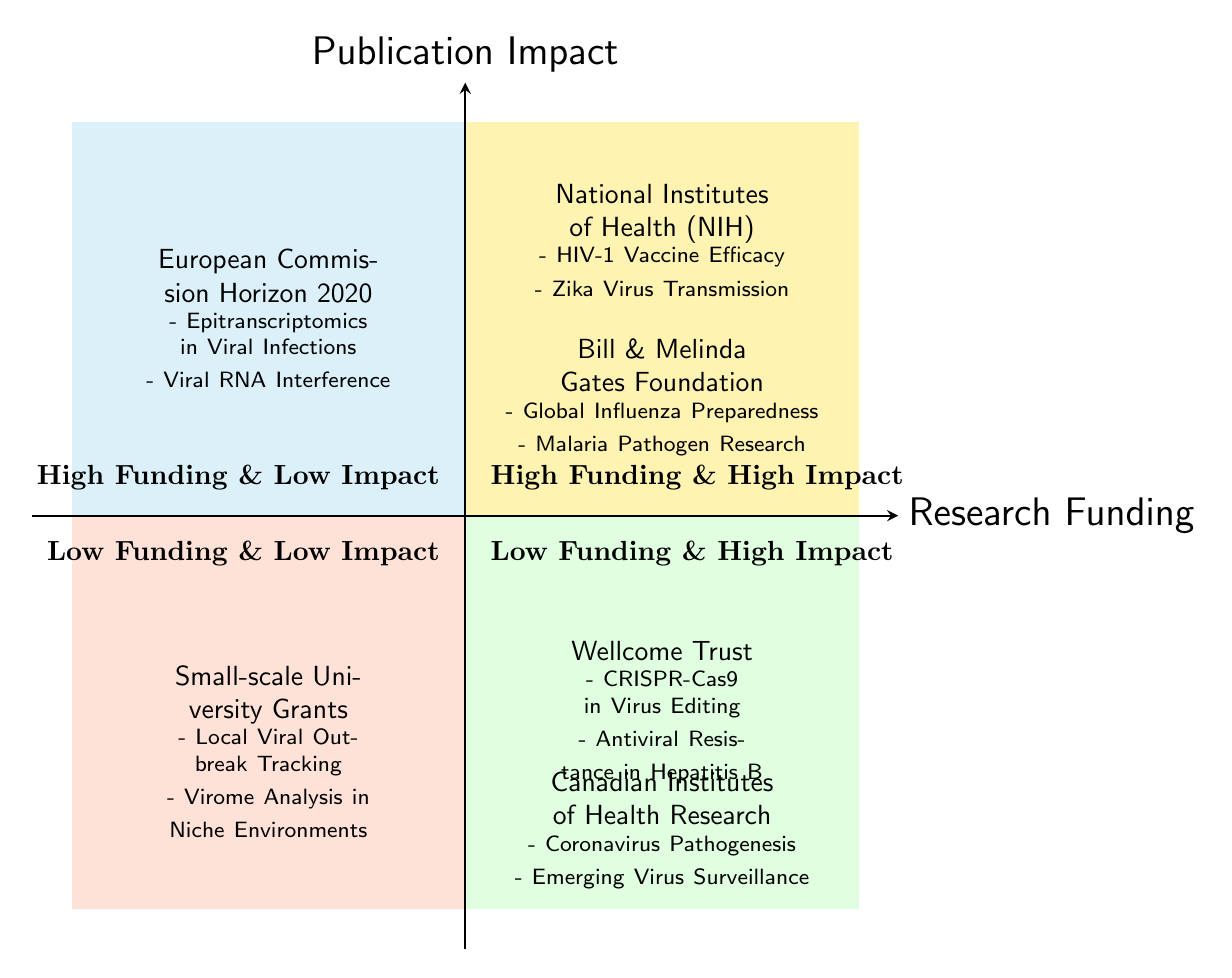What entities are in the "High Funding & High Impact" quadrant? This quadrant includes the entities "National Institutes of Health (NIH)" and "Bill & Melinda Gates Foundation".
Answer: National Institutes of Health (NIH), Bill & Melinda Gates Foundation How many entities are categorized as "Low Funding & Low Impact"? There is only one entity listed in this quadrant, which is "Small-scale University Grants".
Answer: 1 Which entity has low funding but high impact? The quadrants indicate the entities "Wellcome Trust" and "Canadian Institutes of Health Research (CIHR)", both of which show low funding with high impact.
Answer: Wellcome Trust, Canadian Institutes of Health Research (CIHR) What examples studies are associated with "Bill & Melinda Gates Foundation"? The studies include "Global Influenza Preparedness" and "Malaria Pathogen Research".
Answer: Global Influenza Preparedness, Malaria Pathogen Research Which quadrant contains the "European Commission Horizon 2020"? This entity is found in the "High Funding & Low Impact" quadrant.
Answer: High Funding & Low Impact What is the relationship between funding level and publication impact in the quadrant labeled "Low Funding & High Impact"? It suggests that entities in this quadrant can achieve high publication impact despite receiving low funding, indicating efficient use of limited resources.
Answer: Efficient use of limited resources Which quadrant exhibits both high funding and low impact? The "High Funding & Low Impact" quadrant demonstrates this combination.
Answer: High Funding & Low Impact How many example studies are associated with "Wellcome Trust"? There are two example studies cited, which are "CRISPR-Cas9 in Virus Editing" and "Antiviral Resistance in Hepatitis B".
Answer: 2 What is the primary characteristic of studies in the "Low Funding & Low Impact" quadrant? The studies here are likely to be of lesser reach or impact, as they operate with limited funding.
Answer: Limited reach or impact 